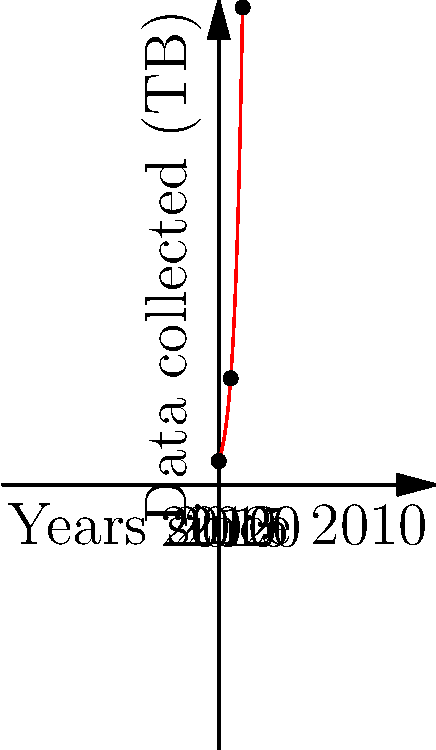The graph shows the growth of data collection over a 10-year period starting from 2010. Based on the exponential trend, approximately how many times larger was the amount of data collected in 2020 compared to 2010? To solve this problem, we need to follow these steps:

1. Identify the data points for 2010 and 2020:
   - 2010 (Year 0): 10 TB
   - 2020 (Year 10): The y-value at x=10 on the graph

2. The graph follows an exponential growth pattern, which can be described by the function:
   $f(x) = 10e^{0.3x}$, where x is the number of years since 2010

3. Calculate the amount of data collected in 2020:
   $f(10) = 10e^{0.3 * 10} = 10e^3 \approx 201$ TB

4. Calculate the ratio of data collected in 2020 compared to 2010:
   $\frac{201 \text{ TB}}{10 \text{ TB}} \approx 20.1$

Therefore, the amount of data collected in 2020 was approximately 20 times larger than in 2010.
Answer: 20 times 